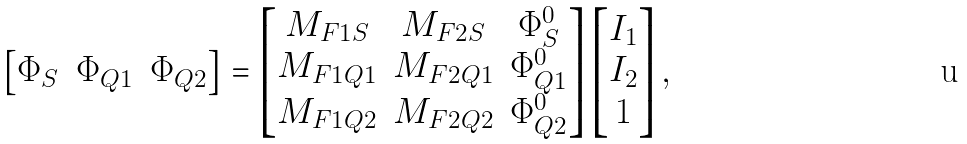Convert formula to latex. <formula><loc_0><loc_0><loc_500><loc_500>\begin{bmatrix} \Phi _ { S } & \Phi _ { Q 1 } & \Phi _ { Q 2 } \end{bmatrix} = \begin{bmatrix} M _ { F 1 S } & M _ { F 2 S } & \Phi _ { S } ^ { 0 } \\ M _ { F 1 Q 1 } & M _ { F 2 Q 1 } & \Phi _ { Q 1 } ^ { 0 } \\ M _ { F 1 Q 2 } & M _ { F 2 Q 2 } & \Phi _ { Q 2 } ^ { 0 } \\ \end{bmatrix} \begin{bmatrix} I _ { 1 } \\ I _ { 2 } \\ 1 \end{bmatrix} ,</formula> 